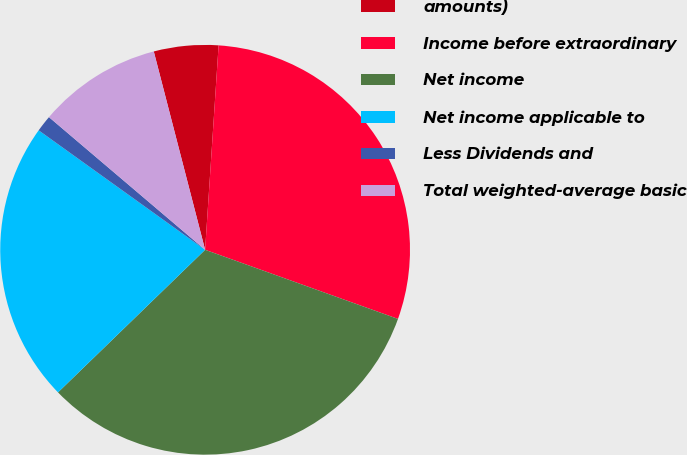Convert chart to OTSL. <chart><loc_0><loc_0><loc_500><loc_500><pie_chart><fcel>amounts)<fcel>Income before extraordinary<fcel>Net income<fcel>Net income applicable to<fcel>Less Dividends and<fcel>Total weighted-average basic<nl><fcel>5.08%<fcel>29.43%<fcel>32.27%<fcel>22.16%<fcel>1.3%<fcel>9.76%<nl></chart> 